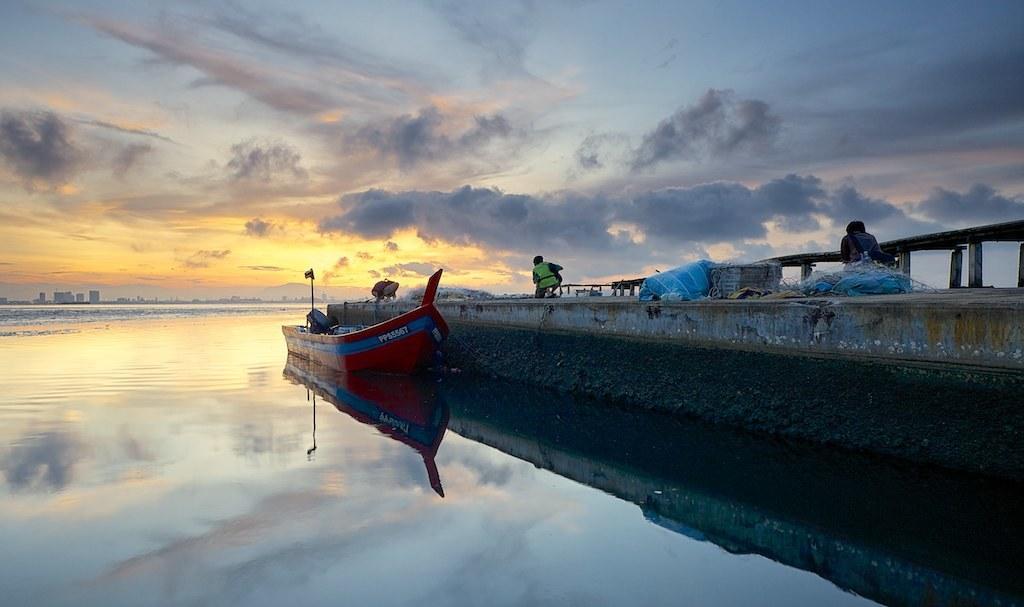Describe this image in one or two sentences. In this image there is water and we can see a boat on the water. On the right there is a wall and we can see people. In the background there is a bridge, buildings and sky. 